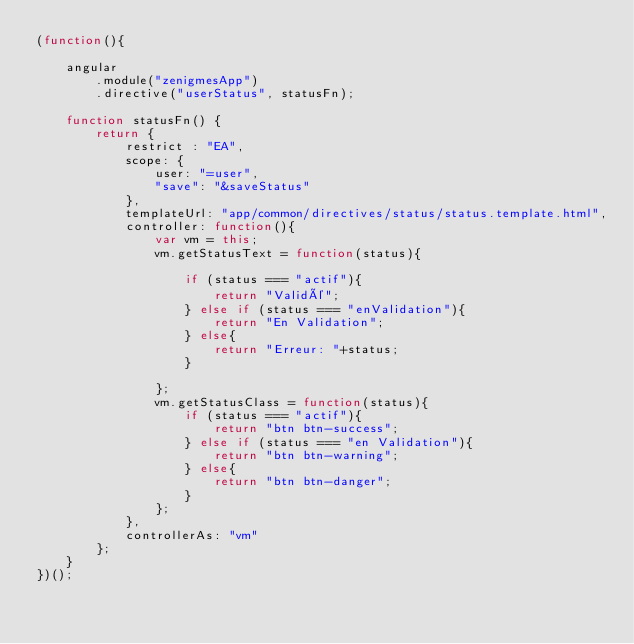Convert code to text. <code><loc_0><loc_0><loc_500><loc_500><_JavaScript_>(function(){

    angular
        .module("zenigmesApp")
        .directive("userStatus", statusFn);

    function statusFn() {
        return {
            restrict : "EA",
            scope: {
                user: "=user",
                "save": "&saveStatus"
            },
            templateUrl: "app/common/directives/status/status.template.html",
            controller: function(){
                var vm = this;
                vm.getStatusText = function(status){
                    
                    if (status === "actif"){
                        return "Validé";
                    } else if (status === "enValidation"){
                        return "En Validation";
                    } else{
                        return "Erreur: "+status;
                    }

                };
                vm.getStatusClass = function(status){
                    if (status === "actif"){
                        return "btn btn-success";
                    } else if (status === "en Validation"){
                        return "btn btn-warning";
                    } else{
                        return "btn btn-danger";
                    }
                };
            },
            controllerAs: "vm"
        };
    }
})();</code> 